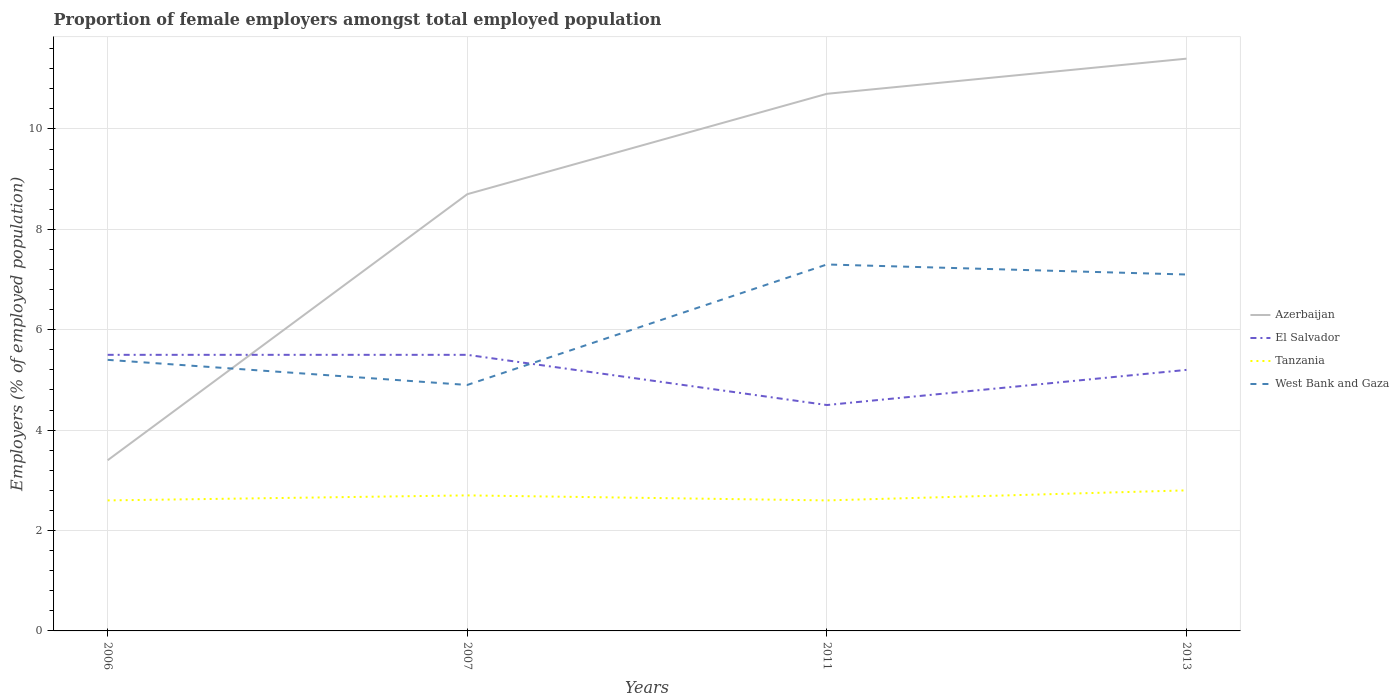What is the total proportion of female employers in West Bank and Gaza in the graph?
Make the answer very short. -2.4. What is the difference between the highest and the second highest proportion of female employers in Azerbaijan?
Keep it short and to the point. 8. What is the difference between the highest and the lowest proportion of female employers in Tanzania?
Your answer should be very brief. 2. Is the proportion of female employers in Tanzania strictly greater than the proportion of female employers in Azerbaijan over the years?
Ensure brevity in your answer.  Yes. How many years are there in the graph?
Offer a very short reply. 4. What is the difference between two consecutive major ticks on the Y-axis?
Your answer should be compact. 2. Does the graph contain any zero values?
Give a very brief answer. No. Does the graph contain grids?
Your response must be concise. Yes. Where does the legend appear in the graph?
Keep it short and to the point. Center right. What is the title of the graph?
Ensure brevity in your answer.  Proportion of female employers amongst total employed population. What is the label or title of the Y-axis?
Provide a short and direct response. Employers (% of employed population). What is the Employers (% of employed population) in Azerbaijan in 2006?
Your answer should be very brief. 3.4. What is the Employers (% of employed population) in El Salvador in 2006?
Your answer should be compact. 5.5. What is the Employers (% of employed population) in Tanzania in 2006?
Your answer should be very brief. 2.6. What is the Employers (% of employed population) of West Bank and Gaza in 2006?
Ensure brevity in your answer.  5.4. What is the Employers (% of employed population) in Azerbaijan in 2007?
Ensure brevity in your answer.  8.7. What is the Employers (% of employed population) in El Salvador in 2007?
Provide a succinct answer. 5.5. What is the Employers (% of employed population) of Tanzania in 2007?
Ensure brevity in your answer.  2.7. What is the Employers (% of employed population) in West Bank and Gaza in 2007?
Your response must be concise. 4.9. What is the Employers (% of employed population) in Azerbaijan in 2011?
Provide a succinct answer. 10.7. What is the Employers (% of employed population) in El Salvador in 2011?
Offer a very short reply. 4.5. What is the Employers (% of employed population) in Tanzania in 2011?
Ensure brevity in your answer.  2.6. What is the Employers (% of employed population) in West Bank and Gaza in 2011?
Make the answer very short. 7.3. What is the Employers (% of employed population) in Azerbaijan in 2013?
Provide a short and direct response. 11.4. What is the Employers (% of employed population) in El Salvador in 2013?
Your response must be concise. 5.2. What is the Employers (% of employed population) of Tanzania in 2013?
Offer a very short reply. 2.8. What is the Employers (% of employed population) in West Bank and Gaza in 2013?
Provide a short and direct response. 7.1. Across all years, what is the maximum Employers (% of employed population) in Azerbaijan?
Ensure brevity in your answer.  11.4. Across all years, what is the maximum Employers (% of employed population) of Tanzania?
Offer a terse response. 2.8. Across all years, what is the maximum Employers (% of employed population) in West Bank and Gaza?
Ensure brevity in your answer.  7.3. Across all years, what is the minimum Employers (% of employed population) of Azerbaijan?
Keep it short and to the point. 3.4. Across all years, what is the minimum Employers (% of employed population) of Tanzania?
Ensure brevity in your answer.  2.6. Across all years, what is the minimum Employers (% of employed population) in West Bank and Gaza?
Provide a succinct answer. 4.9. What is the total Employers (% of employed population) in Azerbaijan in the graph?
Offer a terse response. 34.2. What is the total Employers (% of employed population) of El Salvador in the graph?
Make the answer very short. 20.7. What is the total Employers (% of employed population) in West Bank and Gaza in the graph?
Make the answer very short. 24.7. What is the difference between the Employers (% of employed population) of Tanzania in 2006 and that in 2007?
Ensure brevity in your answer.  -0.1. What is the difference between the Employers (% of employed population) in El Salvador in 2006 and that in 2011?
Give a very brief answer. 1. What is the difference between the Employers (% of employed population) of Tanzania in 2006 and that in 2011?
Provide a short and direct response. 0. What is the difference between the Employers (% of employed population) in West Bank and Gaza in 2006 and that in 2011?
Give a very brief answer. -1.9. What is the difference between the Employers (% of employed population) in Azerbaijan in 2006 and that in 2013?
Offer a very short reply. -8. What is the difference between the Employers (% of employed population) in Tanzania in 2007 and that in 2013?
Offer a very short reply. -0.1. What is the difference between the Employers (% of employed population) of Azerbaijan in 2011 and that in 2013?
Give a very brief answer. -0.7. What is the difference between the Employers (% of employed population) in El Salvador in 2011 and that in 2013?
Offer a very short reply. -0.7. What is the difference between the Employers (% of employed population) of Azerbaijan in 2006 and the Employers (% of employed population) of Tanzania in 2007?
Make the answer very short. 0.7. What is the difference between the Employers (% of employed population) in Azerbaijan in 2006 and the Employers (% of employed population) in El Salvador in 2011?
Provide a short and direct response. -1.1. What is the difference between the Employers (% of employed population) of Azerbaijan in 2006 and the Employers (% of employed population) of West Bank and Gaza in 2011?
Give a very brief answer. -3.9. What is the difference between the Employers (% of employed population) in Tanzania in 2006 and the Employers (% of employed population) in West Bank and Gaza in 2011?
Offer a terse response. -4.7. What is the difference between the Employers (% of employed population) in Azerbaijan in 2006 and the Employers (% of employed population) in Tanzania in 2013?
Provide a short and direct response. 0.6. What is the difference between the Employers (% of employed population) in Tanzania in 2006 and the Employers (% of employed population) in West Bank and Gaza in 2013?
Make the answer very short. -4.5. What is the difference between the Employers (% of employed population) in Azerbaijan in 2007 and the Employers (% of employed population) in Tanzania in 2011?
Provide a succinct answer. 6.1. What is the difference between the Employers (% of employed population) of El Salvador in 2007 and the Employers (% of employed population) of Tanzania in 2011?
Make the answer very short. 2.9. What is the difference between the Employers (% of employed population) of El Salvador in 2007 and the Employers (% of employed population) of West Bank and Gaza in 2011?
Ensure brevity in your answer.  -1.8. What is the difference between the Employers (% of employed population) of Azerbaijan in 2007 and the Employers (% of employed population) of El Salvador in 2013?
Ensure brevity in your answer.  3.5. What is the difference between the Employers (% of employed population) of Azerbaijan in 2007 and the Employers (% of employed population) of West Bank and Gaza in 2013?
Give a very brief answer. 1.6. What is the difference between the Employers (% of employed population) of El Salvador in 2007 and the Employers (% of employed population) of Tanzania in 2013?
Ensure brevity in your answer.  2.7. What is the difference between the Employers (% of employed population) in El Salvador in 2007 and the Employers (% of employed population) in West Bank and Gaza in 2013?
Ensure brevity in your answer.  -1.6. What is the difference between the Employers (% of employed population) in Tanzania in 2007 and the Employers (% of employed population) in West Bank and Gaza in 2013?
Provide a succinct answer. -4.4. What is the difference between the Employers (% of employed population) of Azerbaijan in 2011 and the Employers (% of employed population) of El Salvador in 2013?
Your answer should be compact. 5.5. What is the difference between the Employers (% of employed population) of Azerbaijan in 2011 and the Employers (% of employed population) of West Bank and Gaza in 2013?
Ensure brevity in your answer.  3.6. What is the difference between the Employers (% of employed population) in El Salvador in 2011 and the Employers (% of employed population) in Tanzania in 2013?
Give a very brief answer. 1.7. What is the difference between the Employers (% of employed population) in El Salvador in 2011 and the Employers (% of employed population) in West Bank and Gaza in 2013?
Keep it short and to the point. -2.6. What is the difference between the Employers (% of employed population) of Tanzania in 2011 and the Employers (% of employed population) of West Bank and Gaza in 2013?
Offer a very short reply. -4.5. What is the average Employers (% of employed population) in Azerbaijan per year?
Your answer should be compact. 8.55. What is the average Employers (% of employed population) of El Salvador per year?
Keep it short and to the point. 5.17. What is the average Employers (% of employed population) in Tanzania per year?
Provide a short and direct response. 2.67. What is the average Employers (% of employed population) in West Bank and Gaza per year?
Offer a terse response. 6.17. In the year 2006, what is the difference between the Employers (% of employed population) in Azerbaijan and Employers (% of employed population) in El Salvador?
Provide a short and direct response. -2.1. In the year 2006, what is the difference between the Employers (% of employed population) of Azerbaijan and Employers (% of employed population) of West Bank and Gaza?
Keep it short and to the point. -2. In the year 2006, what is the difference between the Employers (% of employed population) of El Salvador and Employers (% of employed population) of Tanzania?
Give a very brief answer. 2.9. In the year 2006, what is the difference between the Employers (% of employed population) of El Salvador and Employers (% of employed population) of West Bank and Gaza?
Give a very brief answer. 0.1. In the year 2006, what is the difference between the Employers (% of employed population) of Tanzania and Employers (% of employed population) of West Bank and Gaza?
Give a very brief answer. -2.8. In the year 2007, what is the difference between the Employers (% of employed population) in Azerbaijan and Employers (% of employed population) in Tanzania?
Make the answer very short. 6. In the year 2007, what is the difference between the Employers (% of employed population) in Azerbaijan and Employers (% of employed population) in West Bank and Gaza?
Provide a short and direct response. 3.8. In the year 2007, what is the difference between the Employers (% of employed population) of El Salvador and Employers (% of employed population) of Tanzania?
Your response must be concise. 2.8. In the year 2007, what is the difference between the Employers (% of employed population) of El Salvador and Employers (% of employed population) of West Bank and Gaza?
Provide a short and direct response. 0.6. In the year 2007, what is the difference between the Employers (% of employed population) of Tanzania and Employers (% of employed population) of West Bank and Gaza?
Your response must be concise. -2.2. In the year 2011, what is the difference between the Employers (% of employed population) of Azerbaijan and Employers (% of employed population) of El Salvador?
Make the answer very short. 6.2. In the year 2011, what is the difference between the Employers (% of employed population) of Azerbaijan and Employers (% of employed population) of Tanzania?
Provide a succinct answer. 8.1. In the year 2011, what is the difference between the Employers (% of employed population) in Azerbaijan and Employers (% of employed population) in West Bank and Gaza?
Your answer should be compact. 3.4. In the year 2011, what is the difference between the Employers (% of employed population) of El Salvador and Employers (% of employed population) of Tanzania?
Your response must be concise. 1.9. In the year 2011, what is the difference between the Employers (% of employed population) in El Salvador and Employers (% of employed population) in West Bank and Gaza?
Provide a succinct answer. -2.8. In the year 2011, what is the difference between the Employers (% of employed population) of Tanzania and Employers (% of employed population) of West Bank and Gaza?
Your response must be concise. -4.7. In the year 2013, what is the difference between the Employers (% of employed population) of Azerbaijan and Employers (% of employed population) of Tanzania?
Make the answer very short. 8.6. In the year 2013, what is the difference between the Employers (% of employed population) in Azerbaijan and Employers (% of employed population) in West Bank and Gaza?
Ensure brevity in your answer.  4.3. In the year 2013, what is the difference between the Employers (% of employed population) in El Salvador and Employers (% of employed population) in West Bank and Gaza?
Offer a very short reply. -1.9. What is the ratio of the Employers (% of employed population) in Azerbaijan in 2006 to that in 2007?
Your response must be concise. 0.39. What is the ratio of the Employers (% of employed population) of Tanzania in 2006 to that in 2007?
Offer a terse response. 0.96. What is the ratio of the Employers (% of employed population) in West Bank and Gaza in 2006 to that in 2007?
Make the answer very short. 1.1. What is the ratio of the Employers (% of employed population) in Azerbaijan in 2006 to that in 2011?
Provide a succinct answer. 0.32. What is the ratio of the Employers (% of employed population) in El Salvador in 2006 to that in 2011?
Provide a short and direct response. 1.22. What is the ratio of the Employers (% of employed population) of Tanzania in 2006 to that in 2011?
Ensure brevity in your answer.  1. What is the ratio of the Employers (% of employed population) of West Bank and Gaza in 2006 to that in 2011?
Give a very brief answer. 0.74. What is the ratio of the Employers (% of employed population) in Azerbaijan in 2006 to that in 2013?
Ensure brevity in your answer.  0.3. What is the ratio of the Employers (% of employed population) of El Salvador in 2006 to that in 2013?
Give a very brief answer. 1.06. What is the ratio of the Employers (% of employed population) in Tanzania in 2006 to that in 2013?
Ensure brevity in your answer.  0.93. What is the ratio of the Employers (% of employed population) of West Bank and Gaza in 2006 to that in 2013?
Your answer should be very brief. 0.76. What is the ratio of the Employers (% of employed population) of Azerbaijan in 2007 to that in 2011?
Make the answer very short. 0.81. What is the ratio of the Employers (% of employed population) in El Salvador in 2007 to that in 2011?
Offer a terse response. 1.22. What is the ratio of the Employers (% of employed population) of Tanzania in 2007 to that in 2011?
Your response must be concise. 1.04. What is the ratio of the Employers (% of employed population) of West Bank and Gaza in 2007 to that in 2011?
Give a very brief answer. 0.67. What is the ratio of the Employers (% of employed population) in Azerbaijan in 2007 to that in 2013?
Keep it short and to the point. 0.76. What is the ratio of the Employers (% of employed population) in El Salvador in 2007 to that in 2013?
Provide a short and direct response. 1.06. What is the ratio of the Employers (% of employed population) of Tanzania in 2007 to that in 2013?
Ensure brevity in your answer.  0.96. What is the ratio of the Employers (% of employed population) in West Bank and Gaza in 2007 to that in 2013?
Your response must be concise. 0.69. What is the ratio of the Employers (% of employed population) of Azerbaijan in 2011 to that in 2013?
Give a very brief answer. 0.94. What is the ratio of the Employers (% of employed population) of El Salvador in 2011 to that in 2013?
Your response must be concise. 0.87. What is the ratio of the Employers (% of employed population) of Tanzania in 2011 to that in 2013?
Your response must be concise. 0.93. What is the ratio of the Employers (% of employed population) in West Bank and Gaza in 2011 to that in 2013?
Your answer should be very brief. 1.03. What is the difference between the highest and the second highest Employers (% of employed population) of Azerbaijan?
Keep it short and to the point. 0.7. What is the difference between the highest and the second highest Employers (% of employed population) in El Salvador?
Your response must be concise. 0. What is the difference between the highest and the second highest Employers (% of employed population) of Tanzania?
Offer a terse response. 0.1. What is the difference between the highest and the lowest Employers (% of employed population) of Azerbaijan?
Provide a short and direct response. 8. What is the difference between the highest and the lowest Employers (% of employed population) in El Salvador?
Ensure brevity in your answer.  1. 